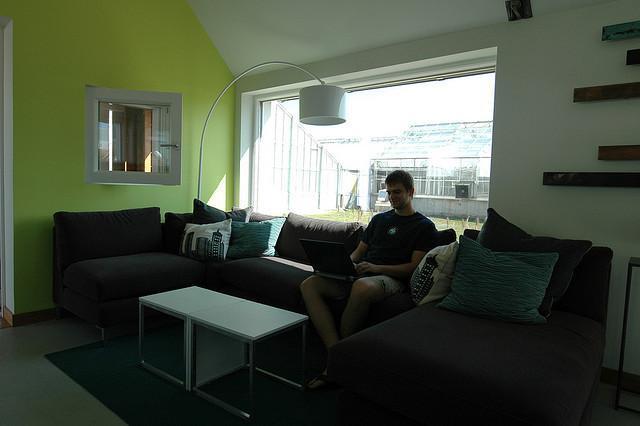How many couches are in the picture?
Give a very brief answer. 2. How many bears are white?
Give a very brief answer. 0. 